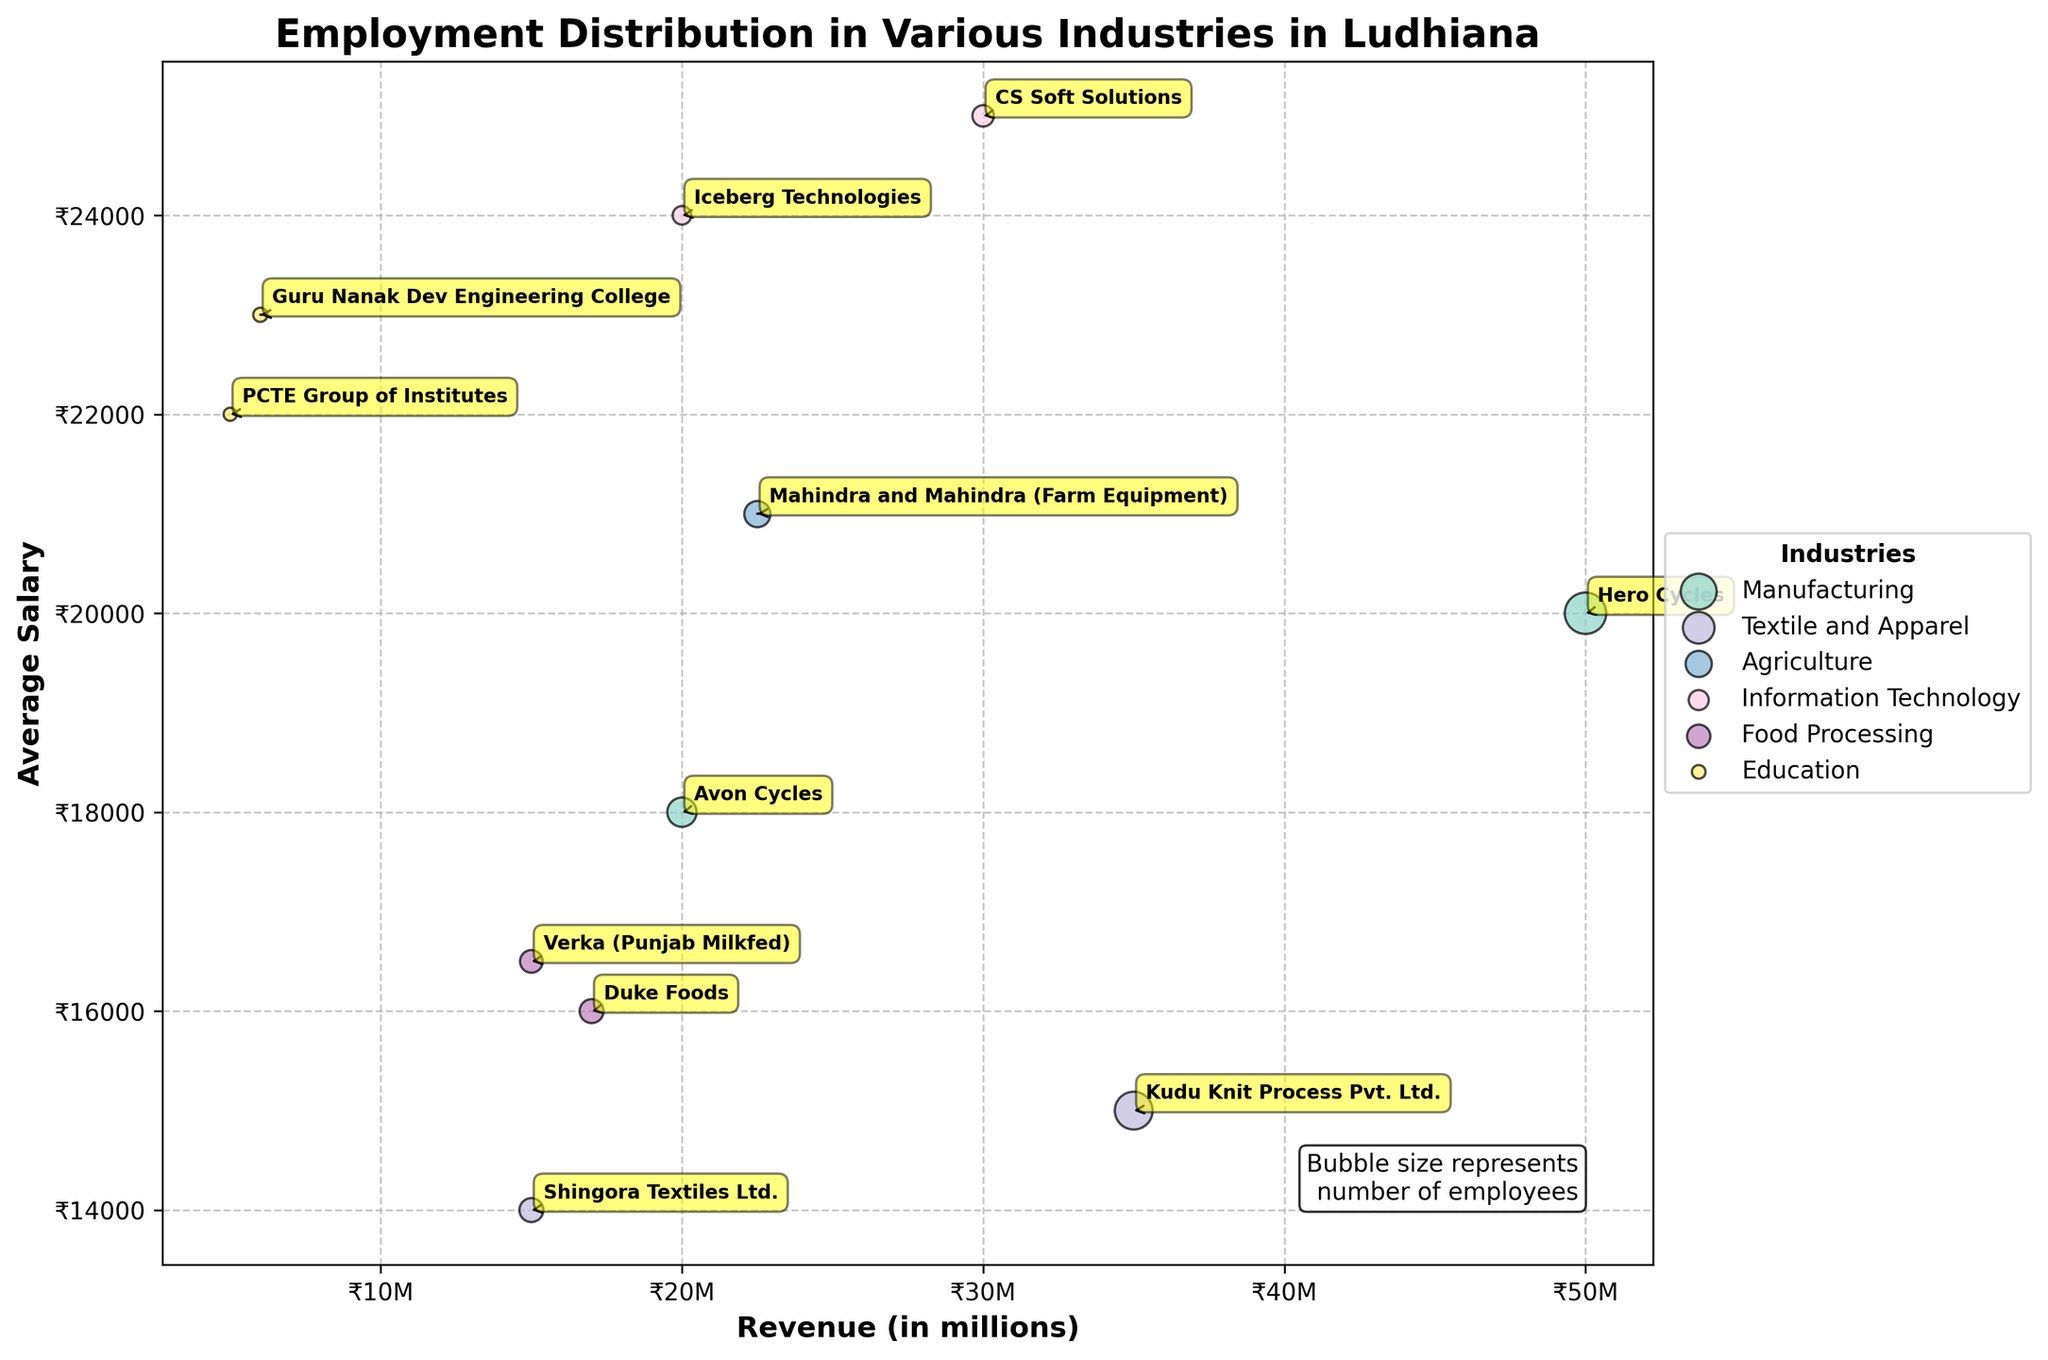What is the title of the bubble chart? The title of the bubble chart is usually placed at the top center and reads "Employment Distribution in Various Industries in Ludhiana."
Answer: Employment Distribution in Various Industries in Ludhiana What is represented by the bubble size in the chart? Each bubble size represents the number of employees in the respective company. This is indicated by text on the chart itself - "Bubble size represents number of employees."
Answer: Number of employees Which industry has the bubble with the highest average salary? By observing the chart, the placement of bubbles and labels indicates that the Information Technology industry has the highest average salary since the corresponding bubbles (CS Soft Solutions and Iceberg Technologies) are at the higher end of the y-axis (Average Salary).
Answer: Information Technology Which company in the Manufacturing industry has more employees, Hero Cycles or Avon Cycles? By comparing the bubble sizes for Hero Cycles and Avon Cycles within the Manufacturing industry, Hero Cycles has a larger bubble, indicating more employees.
Answer: Hero Cycles Which industry has the highest revenue combined from all companies? Summing up the revenues for each company in each industry:
Manufacturing: 50M + 20M = 70M;
Textile and Apparel: 35M + 15M = 50M;
Agriculture: 22.5M;
Information Technology: 30M + 20M = 50M;
Food Processing: 17M + 15M = 32M;
Education: 5M + 6M = 11M.
Manufacturing has the highest combined revenue.
Answer: Manufacturing Which company has the lowest average salary in the bubble chart? By examining the y-axis (Average Salary) and looking for the lowest point, Shingora Textiles Ltd. under Textile and Apparel industry has the lowest average salary of ₹14,000.
Answer: Shingora Textiles Ltd How many companies from the Food Processing industry are featured in the bubble chart? The chart shows two bubbles for companies in the Food Processing industry: Duke Foods and Verka (Punjab Milkfed).
Answer: Two Compare the number of employees in Mahindra and Mahindra (Farm Equipment) to that in Duke Foods. Which company has more employees? By observing the bubble sizes, Mahindra and Mahindra (Farm Equipment) has a larger bubble size (1200 employees) compared to Duke Foods (1000 employees), indicating it has more employees.
Answer: Mahindra and Mahindra (Farm Equipment) Which company in the Information Technology industry has the higher revenue, CS Soft Solutions or Iceberg Technologies? Observing the x-axis (Revenue), CS Soft Solutions has a higher revenue (₹30 million) compared to Iceberg Technologies (₹20 million).
Answer: CS Soft Solutions 